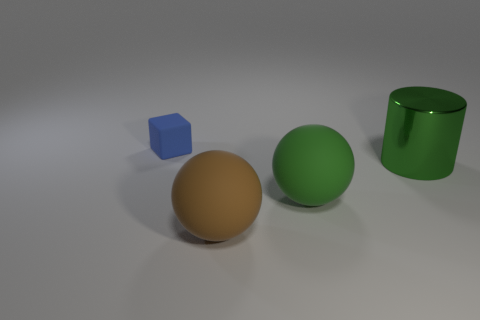There is a large matte thing that is to the right of the big brown sphere; is its shape the same as the object behind the large cylinder?
Ensure brevity in your answer.  No. There is a thing that is in front of the large shiny object and behind the large brown matte object; what size is it?
Make the answer very short. Large. What number of other objects are there of the same color as the large shiny cylinder?
Keep it short and to the point. 1. Do the big object that is in front of the big green sphere and the small blue object have the same material?
Offer a very short reply. Yes. Is there any other thing that has the same size as the cube?
Make the answer very short. No. Is the number of brown objects behind the green metal cylinder less than the number of rubber blocks behind the brown ball?
Provide a succinct answer. Yes. Is there anything else that has the same shape as the metallic thing?
Give a very brief answer. No. What is the material of the large object that is the same color as the cylinder?
Ensure brevity in your answer.  Rubber. There is a big matte sphere in front of the green thing that is in front of the shiny object; what number of tiny blue objects are right of it?
Ensure brevity in your answer.  0. There is a tiny matte object; how many matte things are behind it?
Give a very brief answer. 0. 